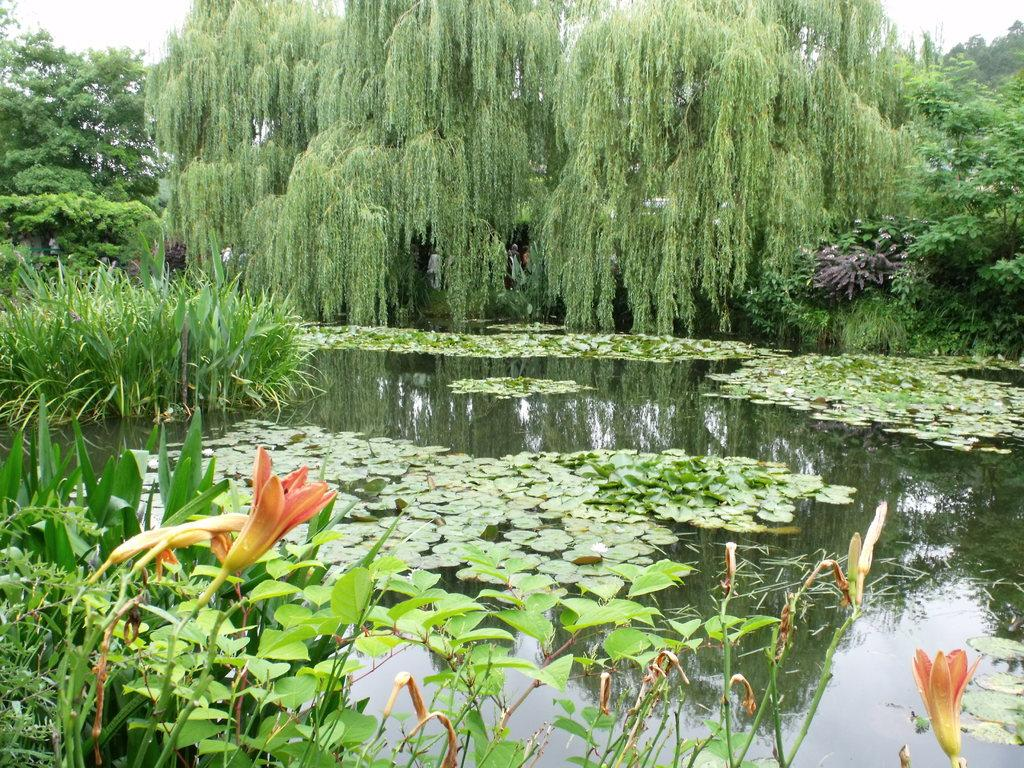What type of vegetation can be seen in the image? There are trees in the image. What else can be seen besides trees in the image? There is water and the sky visible in the image. What colors are the flowers in the image? The flowers in the image are orange and yellow. What type of committee is meeting in the image? There is no committee meeting in the image; it features trees, water, the sky, and flowers. How many people are attending the party in the image? There is no party present in the image; it features natural elements such as trees, water, the sky, and flowers. 